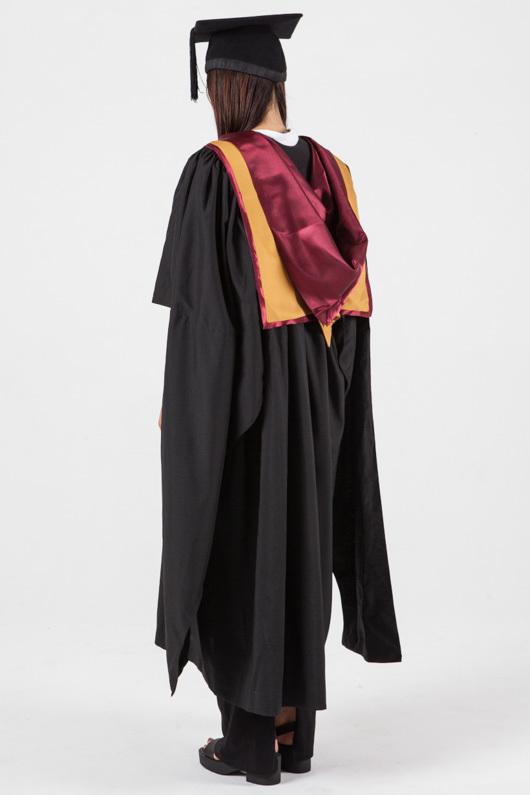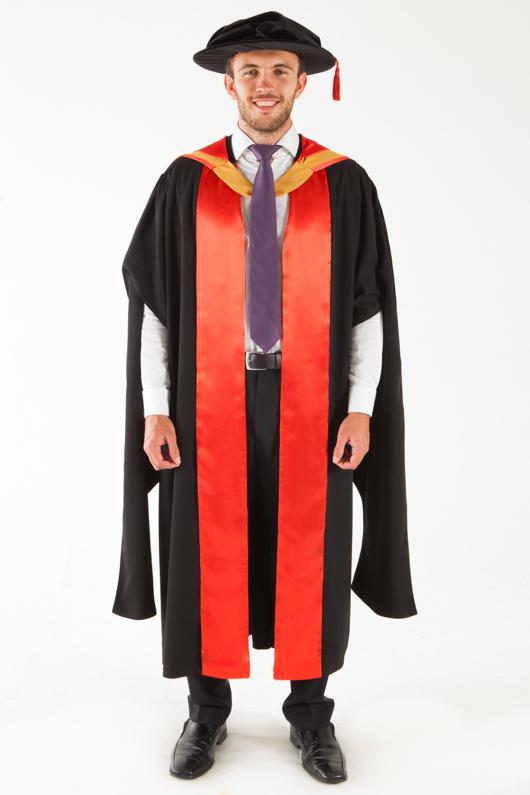The first image is the image on the left, the second image is the image on the right. Considering the images on both sides, is "There are two women in graduation clothes facing the camera." valid? Answer yes or no. No. The first image is the image on the left, the second image is the image on the right. Assess this claim about the two images: "women facing forward in a cap and gown". Correct or not? Answer yes or no. No. 